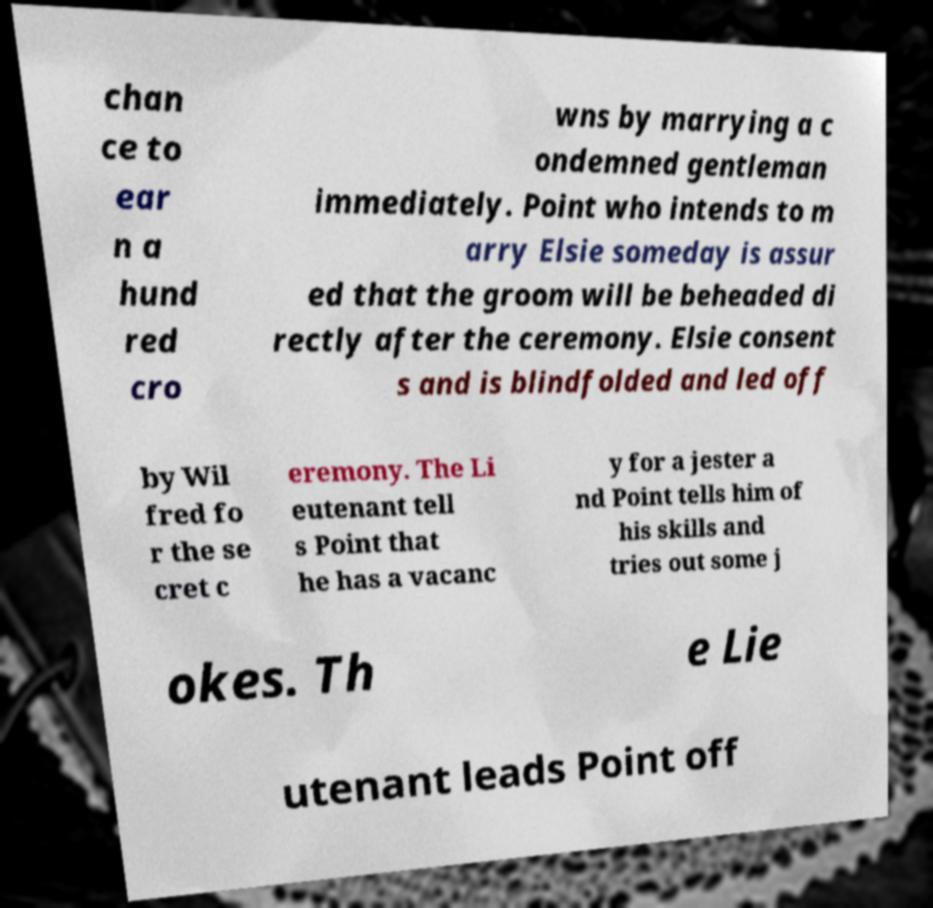Could you assist in decoding the text presented in this image and type it out clearly? chan ce to ear n a hund red cro wns by marrying a c ondemned gentleman immediately. Point who intends to m arry Elsie someday is assur ed that the groom will be beheaded di rectly after the ceremony. Elsie consent s and is blindfolded and led off by Wil fred fo r the se cret c eremony. The Li eutenant tell s Point that he has a vacanc y for a jester a nd Point tells him of his skills and tries out some j okes. Th e Lie utenant leads Point off 